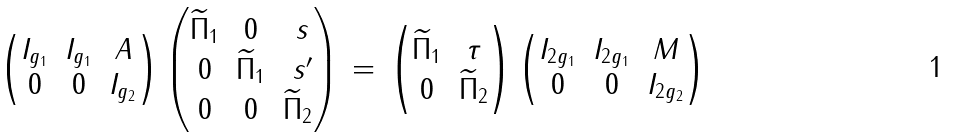Convert formula to latex. <formula><loc_0><loc_0><loc_500><loc_500>\begin{pmatrix} I _ { g _ { 1 } } & I _ { g _ { 1 } } & A \\ 0 & 0 & I _ { g _ { 2 } } \end{pmatrix} \begin{pmatrix} { \widetilde { \Pi } } _ { 1 } & 0 & \ s \\ 0 & { \widetilde { \Pi } } _ { 1 } & \ s ^ { \prime } \\ 0 & 0 & { \widetilde { \Pi } } _ { 2 } \end{pmatrix} \, = \, \begin{pmatrix} { \widetilde { \Pi } } _ { 1 } & \tau \\ 0 & { \widetilde { \Pi } } _ { 2 } \end{pmatrix} \begin{pmatrix} I _ { 2 g _ { 1 } } & I _ { 2 g _ { 1 } } & M \\ 0 & 0 & I _ { 2 g _ { 2 } } \end{pmatrix}</formula> 